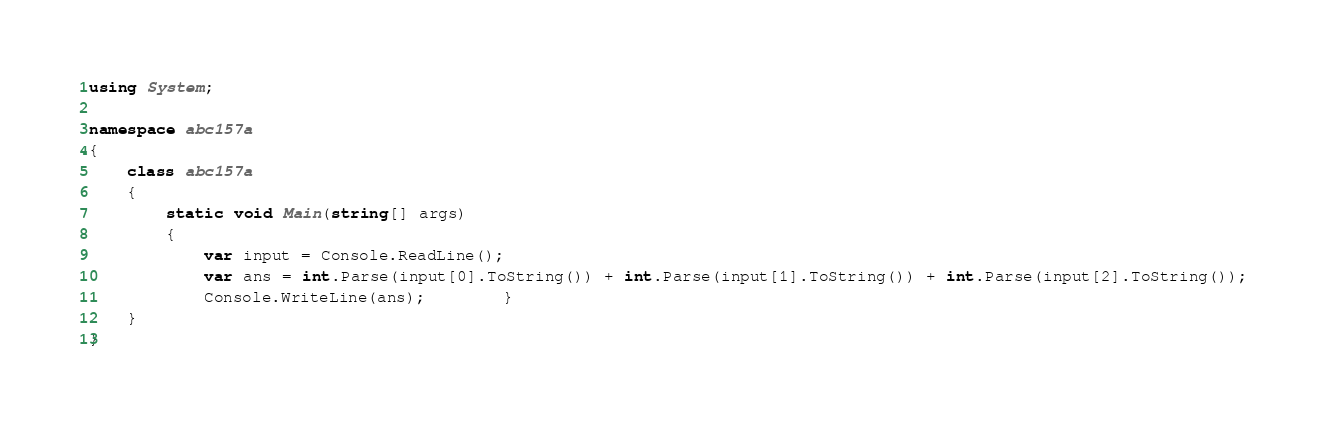Convert code to text. <code><loc_0><loc_0><loc_500><loc_500><_C#_>using System;

namespace abc157a
{
    class abc157a
    {
        static void Main(string[] args)
        {
            var input = Console.ReadLine();
            var ans = int.Parse(input[0].ToString()) + int.Parse(input[1].ToString()) + int.Parse(input[2].ToString());
            Console.WriteLine(ans);        }
    }
}
</code> 